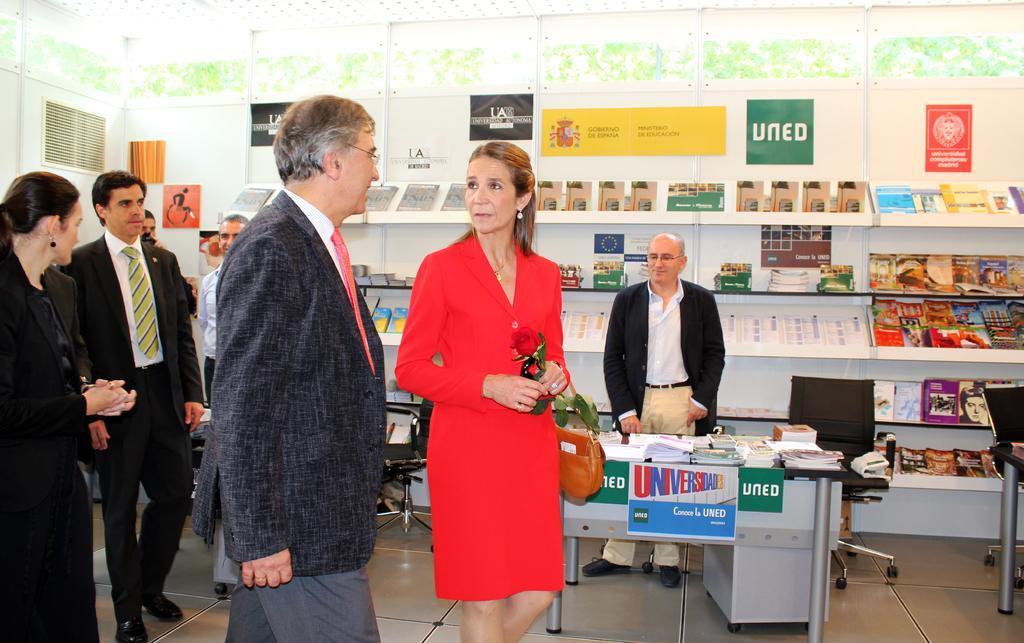How would you summarize this image in a sentence or two? In this image we can see some people standing on the floor. A woman holding a red rose. On the backside we can see a table full of books and some chairs. A person standing behind the table. We can also see some books in the shelves. 